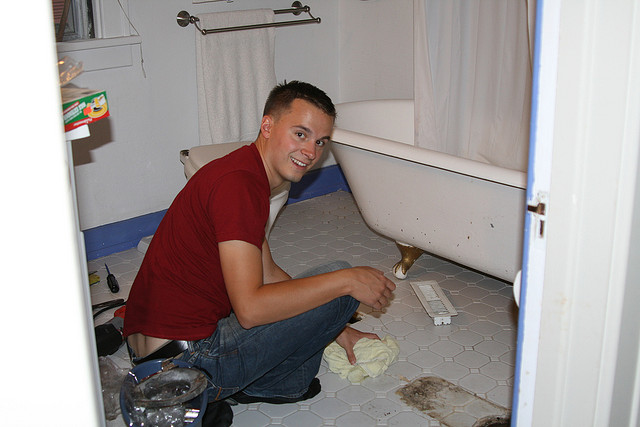If this bathroom could speak, what story would it tell about this moment? If this bathroom could speak, it might tell the story of a hardworking individual who decided to take on a home improvement project. It could recount how the bathroom experienced a slight problem, perhaps a minor plumbing issue under the bathtub that caused some trouble. However, with determination and a positive attitude, as indicated by his smile, the man tackled the issue head-on. The bathroom would narrate how it felt relief as tools were brought out and used skillfully to fix it. Afterward, it was thoroughly cleaned, feeling refreshed and ready to be used again comfortably. Can you imagine a creative plot or story for this scene? In a creative twist, imagine this bathroom as the secret setting for an undercover inventor’s latest creation. The man in the image is actually a brilliant young inventor, disguising his lab as an ordinary bathroom to keep his inventions hidden. Today, he's working on his latest project: a multipurpose tool that can clean, repair, and even perform minor surgeries! The screwdriver is part of his innovative toolkit, and the folded towel holds nano-cleaning bots. While it looks like he’s simply cleaning or fixing the bathroom, he’s actually testing his new invention's capabilities. The white shower curtain hides his most recent creation: a device that can make any space appear completely different, allowing him to change his lab into a library, workshop, or anything he needs with a press of a button. 